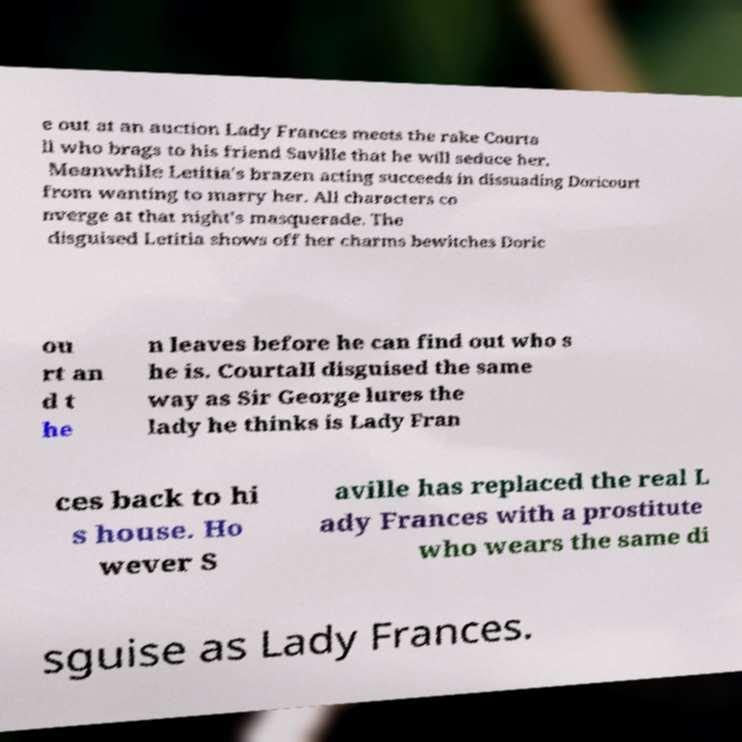For documentation purposes, I need the text within this image transcribed. Could you provide that? e out at an auction Lady Frances meets the rake Courta ll who brags to his friend Saville that he will seduce her. Meanwhile Letitia's brazen acting succeeds in dissuading Doricourt from wanting to marry her. All characters co nverge at that night's masquerade. The disguised Letitia shows off her charms bewitches Doric ou rt an d t he n leaves before he can find out who s he is. Courtall disguised the same way as Sir George lures the lady he thinks is Lady Fran ces back to hi s house. Ho wever S aville has replaced the real L ady Frances with a prostitute who wears the same di sguise as Lady Frances. 